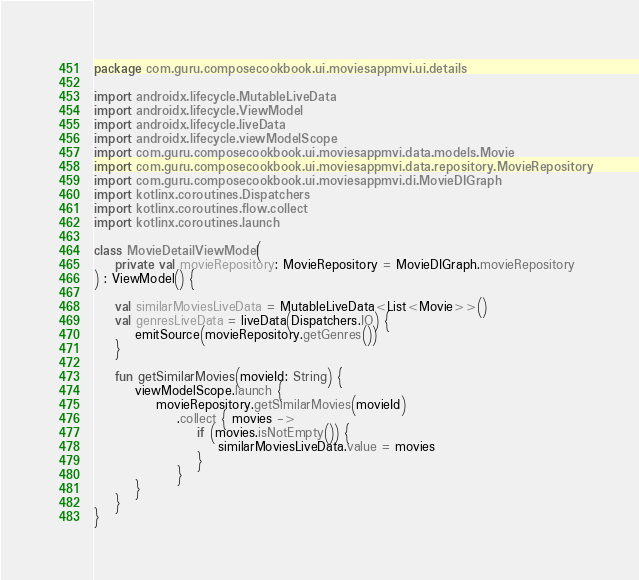Convert code to text. <code><loc_0><loc_0><loc_500><loc_500><_Kotlin_>package com.guru.composecookbook.ui.moviesappmvi.ui.details

import androidx.lifecycle.MutableLiveData
import androidx.lifecycle.ViewModel
import androidx.lifecycle.liveData
import androidx.lifecycle.viewModelScope
import com.guru.composecookbook.ui.moviesappmvi.data.models.Movie
import com.guru.composecookbook.ui.moviesappmvi.data.repository.MovieRepository
import com.guru.composecookbook.ui.moviesappmvi.di.MovieDIGraph
import kotlinx.coroutines.Dispatchers
import kotlinx.coroutines.flow.collect
import kotlinx.coroutines.launch

class MovieDetailViewModel(
    private val movieRepository: MovieRepository = MovieDIGraph.movieRepository
) : ViewModel() {

    val similarMoviesLiveData = MutableLiveData<List<Movie>>()
    val genresLiveData = liveData(Dispatchers.IO) {
        emitSource(movieRepository.getGenres())
    }

    fun getSimilarMovies(movieId: String) {
        viewModelScope.launch {
            movieRepository.getSimilarMovies(movieId)
                .collect { movies ->
                    if (movies.isNotEmpty()) {
                        similarMoviesLiveData.value = movies
                    }
                }
        }
    }
}</code> 